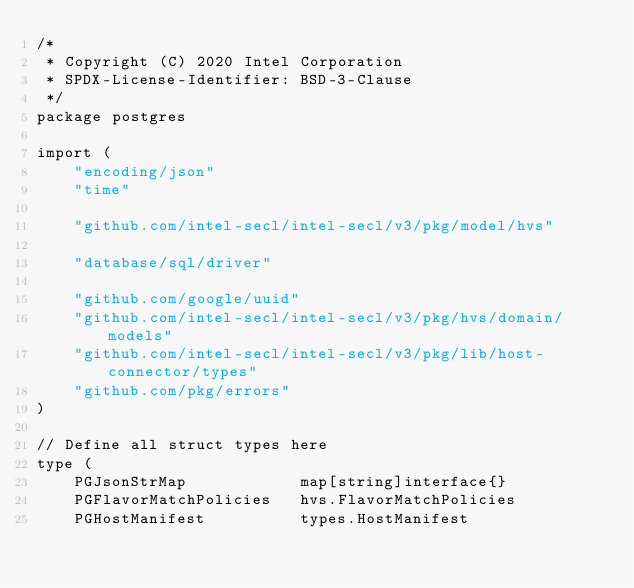<code> <loc_0><loc_0><loc_500><loc_500><_Go_>/*
 * Copyright (C) 2020 Intel Corporation
 * SPDX-License-Identifier: BSD-3-Clause
 */
package postgres

import (
	"encoding/json"
	"time"

	"github.com/intel-secl/intel-secl/v3/pkg/model/hvs"

	"database/sql/driver"

	"github.com/google/uuid"
	"github.com/intel-secl/intel-secl/v3/pkg/hvs/domain/models"
	"github.com/intel-secl/intel-secl/v3/pkg/lib/host-connector/types"
	"github.com/pkg/errors"
)

// Define all struct types here
type (
	PGJsonStrMap            map[string]interface{}
	PGFlavorMatchPolicies   hvs.FlavorMatchPolicies
	PGHostManifest          types.HostManifest</code> 